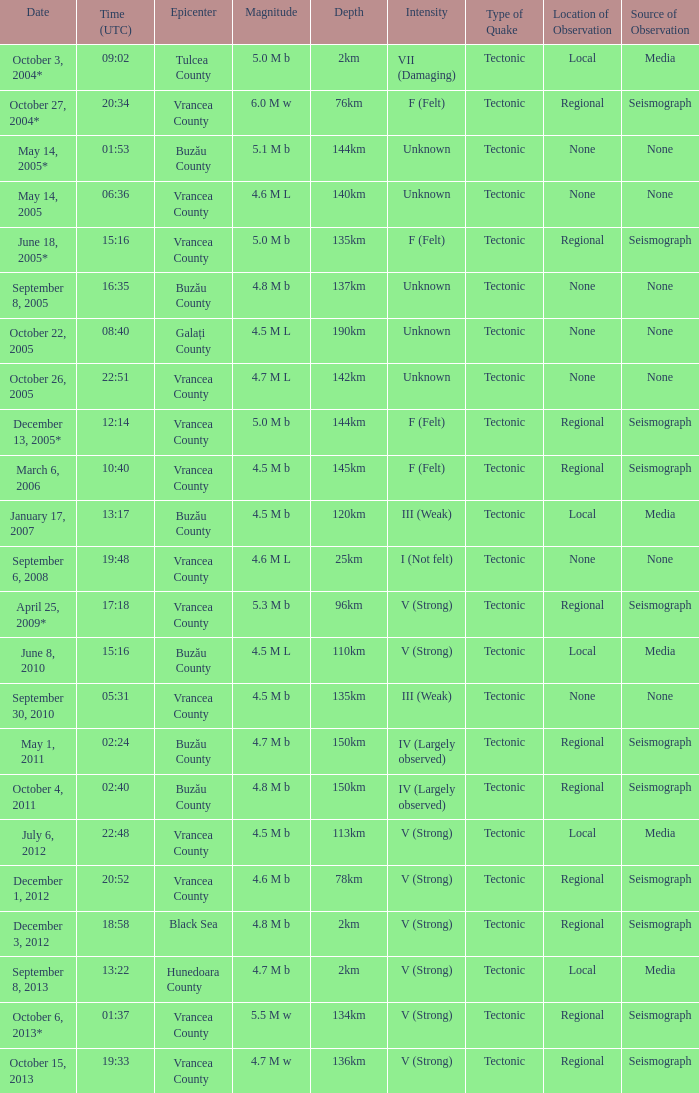What is the magnitude with epicenter at Vrancea County, unknown intensity and which happened at 06:36? 4.6 M L. 